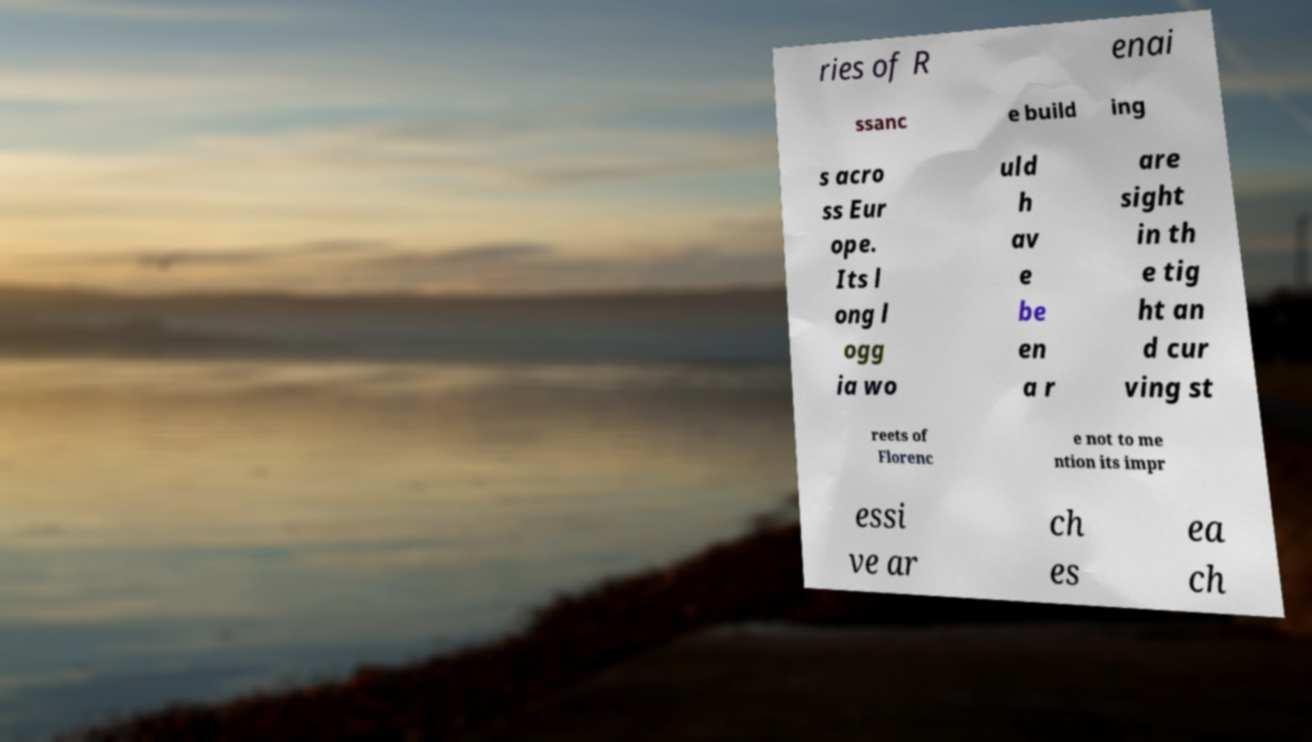What messages or text are displayed in this image? I need them in a readable, typed format. ries of R enai ssanc e build ing s acro ss Eur ope. Its l ong l ogg ia wo uld h av e be en a r are sight in th e tig ht an d cur ving st reets of Florenc e not to me ntion its impr essi ve ar ch es ea ch 